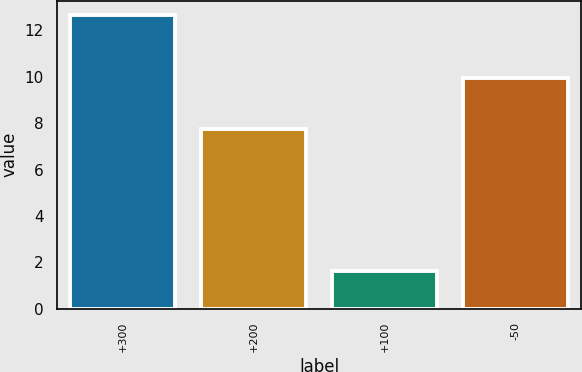Convert chart to OTSL. <chart><loc_0><loc_0><loc_500><loc_500><bar_chart><fcel>+300<fcel>+200<fcel>+100<fcel>-50<nl><fcel>12.65<fcel>7.75<fcel>1.62<fcel>9.94<nl></chart> 